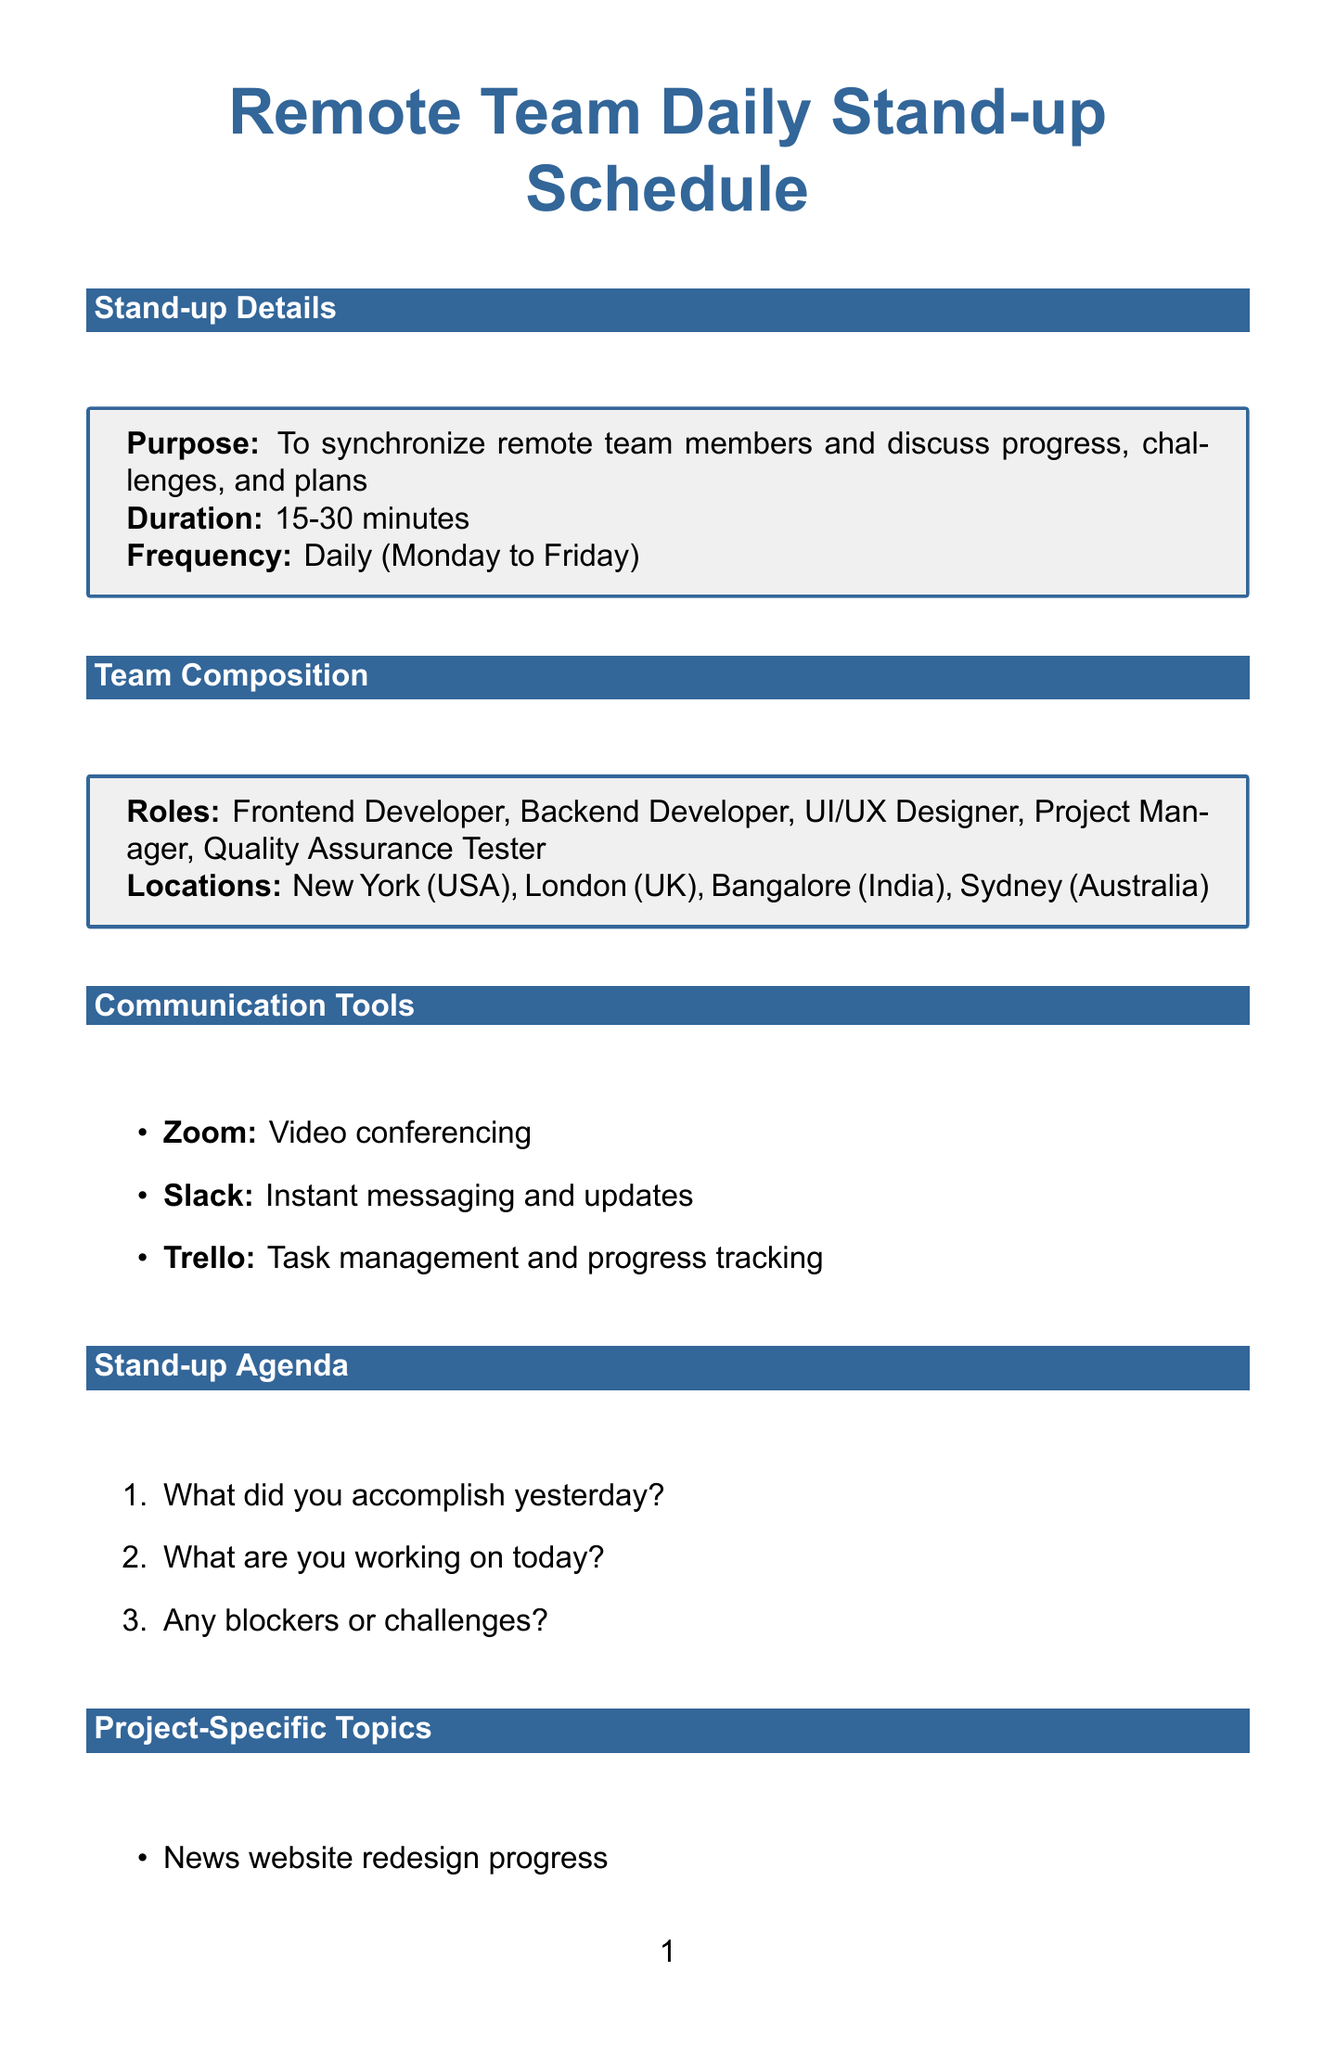What is the duration of the stand-up calls? The duration of the stand-up calls is stated in the document as 15-30 minutes.
Answer: 15-30 minutes How often are the stand-up calls scheduled? The frequency of the stand-up calls is mentioned as daily from Monday to Friday.
Answer: Daily (Monday to Friday) What tool is used for video conferencing? The document lists Zoom as the tool used for video conferencing.
Answer: Zoom Which time zone corresponds to Bangalore? The document specifies India's time zone as India Standard Time.
Answer: India Standard Time (IST) How many project-specific topics are listed? The document provides a list of project-specific topics, and there are five of them.
Answer: 5 What is the local time for Monday's stand-up call in London? The document states that the local time for Monday's stand-up call in London is 02:00 PM.
Answer: 02:00 PM Which team member is located in Sydney? The document identifies Michael Wong as the team member located in Sydney, Australia.
Answer: Michael Wong What are the best practices for meetings? The document lists several best practices for meetings, including rotating meeting times and recording meetings.
Answer: Rotate meeting times to accommodate different time zones What time is the stand-up call on Wednesday in New York? The document indicates that the stand-up call on Wednesday takes place at 12:00 AM in New York.
Answer: 12:00 AM 